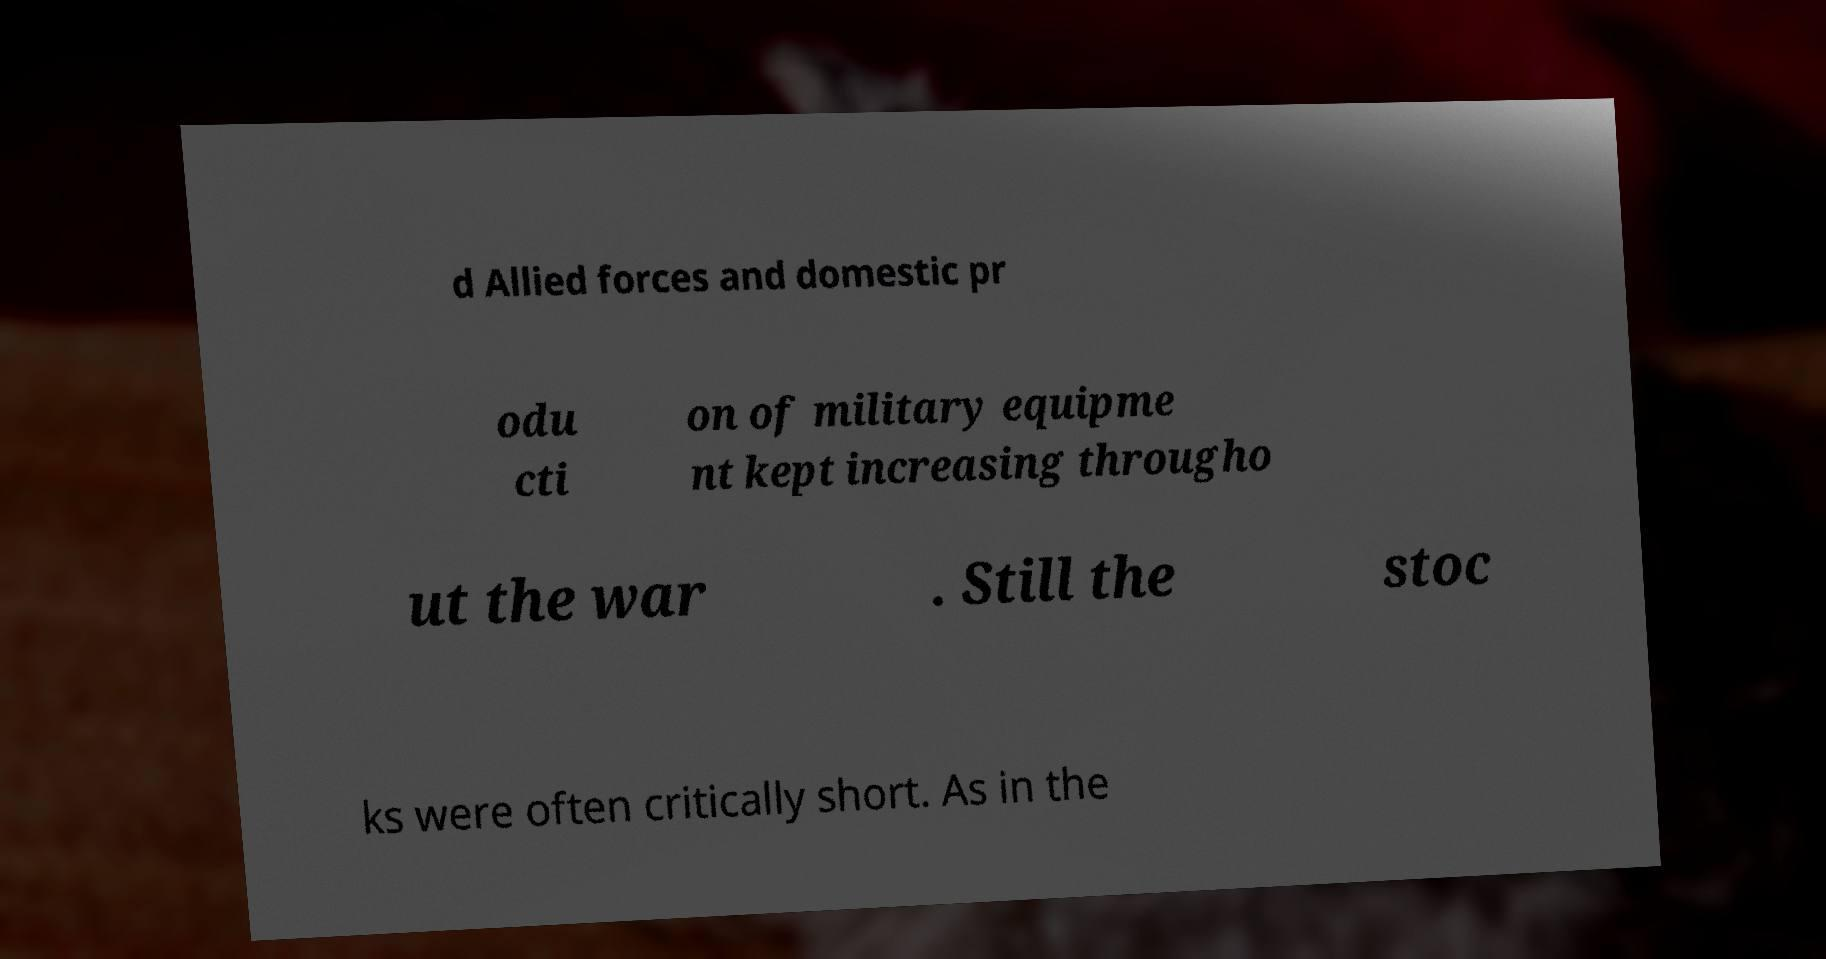Please identify and transcribe the text found in this image. d Allied forces and domestic pr odu cti on of military equipme nt kept increasing througho ut the war . Still the stoc ks were often critically short. As in the 